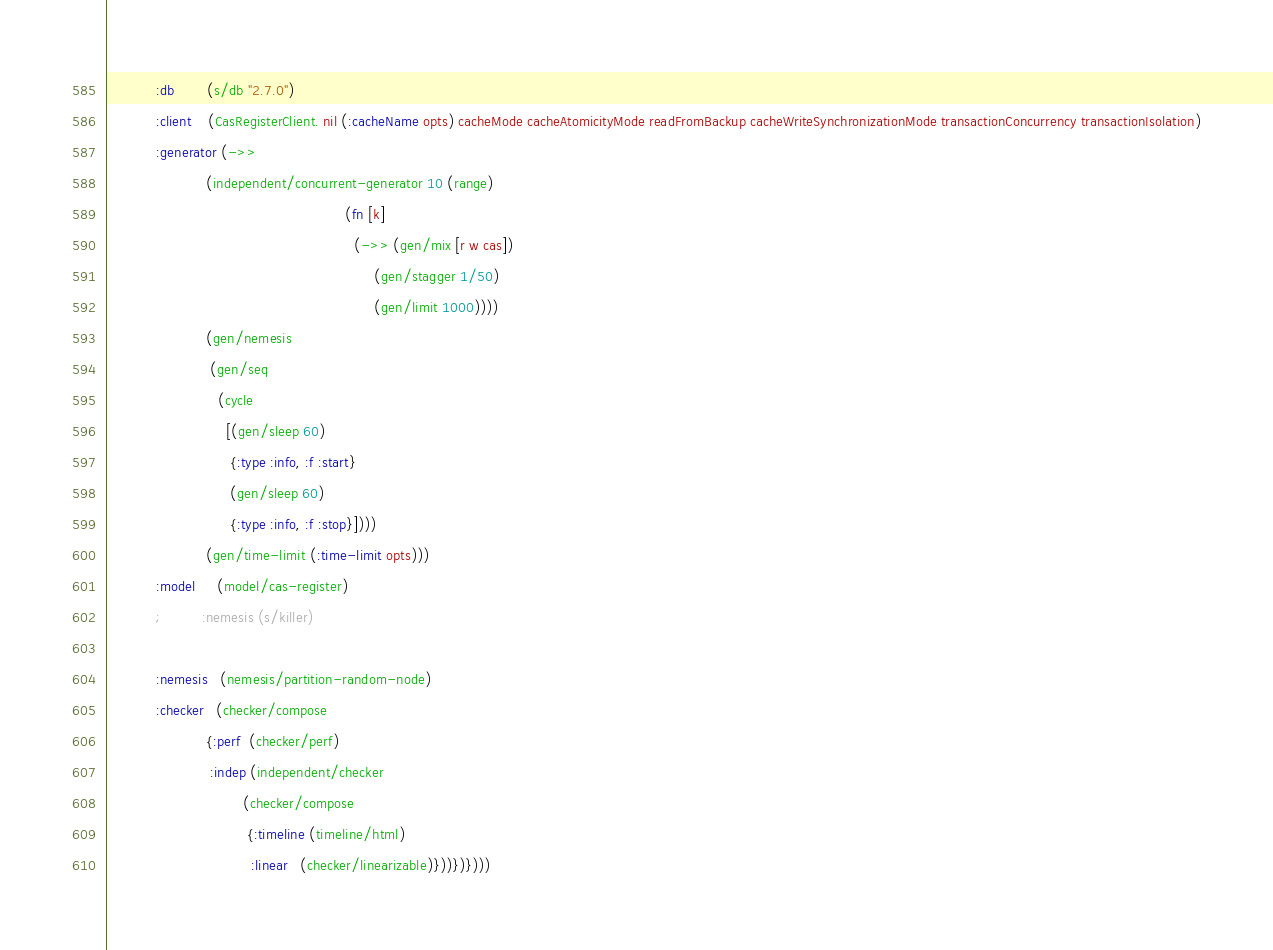Convert code to text. <code><loc_0><loc_0><loc_500><loc_500><_Clojure_>            :db        (s/db "2.7.0")
            :client    (CasRegisterClient. nil (:cacheName opts) cacheMode cacheAtomicityMode readFromBackup cacheWriteSynchronizationMode transactionConcurrency transactionIsolation)
            :generator (->>
                        (independent/concurrent-generator 10 (range)
                                                          (fn [k]
                                                            (->> (gen/mix [r w cas])
                                                                 (gen/stagger 1/50)
                                                                 (gen/limit 1000))))
                        (gen/nemesis
                         (gen/seq
                           (cycle
                             [(gen/sleep 60)
                              {:type :info, :f :start}
                              (gen/sleep 60)
                              {:type :info, :f :stop}])))
                        (gen/time-limit (:time-limit opts)))
            :model     (model/cas-register)
            ;          :nemesis (s/killer)

            :nemesis   (nemesis/partition-random-node)
            :checker   (checker/compose
                        {:perf  (checker/perf)
                         :indep (independent/checker
                                 (checker/compose
                                  {:timeline (timeline/html)
                                   :linear   (checker/linearizable)}))})})))</code> 